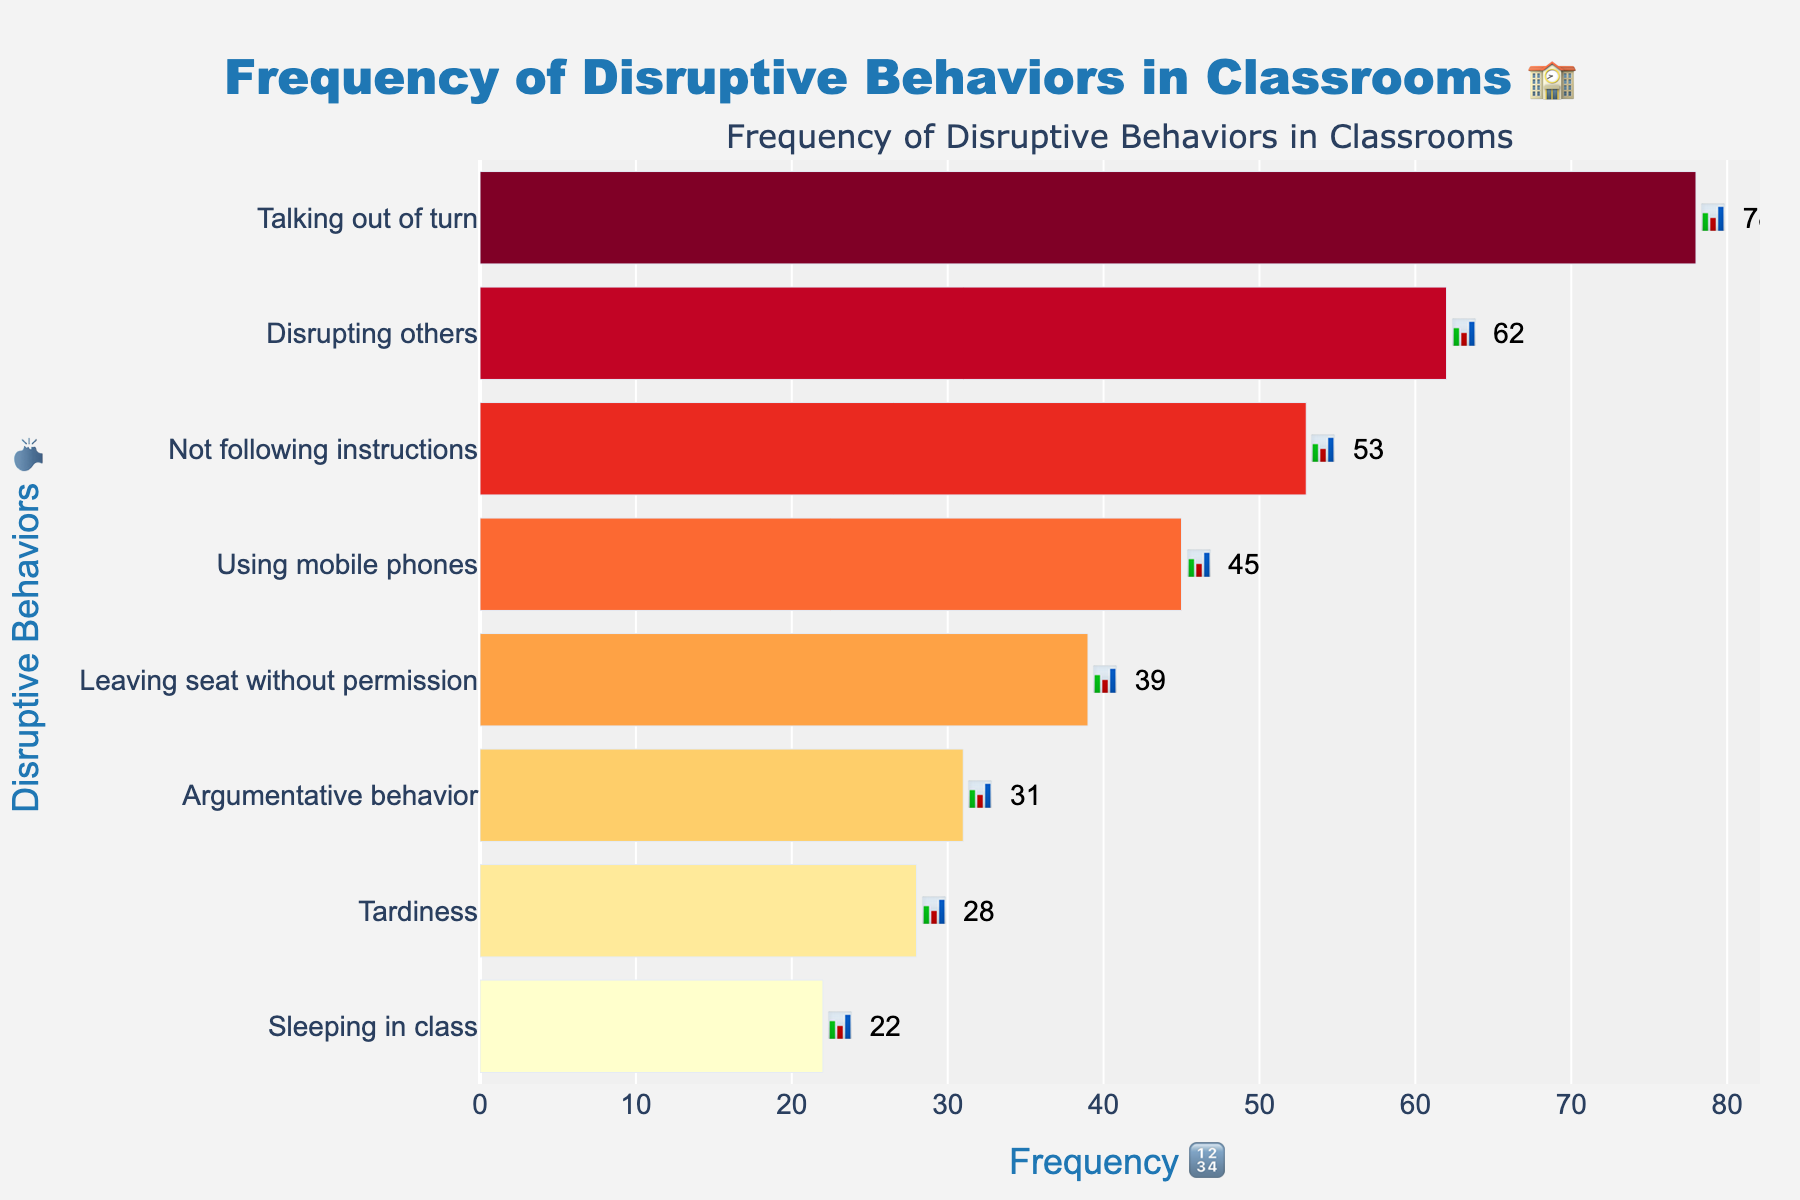What's the title of the chart? The title of the chart is located at the top and is emphasized in larger, bold text. It reads "Frequency of Disruptive Behaviors in Classrooms 🏫".
Answer: Frequency of Disruptive Behaviors in Classrooms 🏫 How many types of disruptive behaviors are reported in the chart? Count the number of different behaviors listed on the y-axis. There are eight types.
Answer: 8 Which disruptive behavior is reported the most frequently? The behavior with the highest bar length represents the highest frequency. "Talking out of turn" has the longest bar.
Answer: Talking out of turn What is the frequency of using mobile phones in class? Locate “Using mobile phones” on the y-axis and find its corresponding bar's length labeled with text. The frequency is 45.
Answer: 45 Which disruptive behavior has the lowest reported frequency? The behavior with the shortest bar is “Sleeping in class,” with a frequency of 22.
Answer: Sleeping in class What is the combined frequency of "Not following instructions" and "Leaving seat without permission"? Add the frequencies of the two behaviors: 53 (Not following instructions) + 39 (Leaving seat without permission). 53 + 39 = 92.
Answer: 92 Are there any behaviors with a frequency greater than 60? If so, which ones? Compare the frequencies of all behaviors to 60. Both "Talking out of turn" (78) and "Disrupting others" (62) have frequencies greater than 60.
Answer: Talking out of turn, Disrupting others How much more frequently is "Argumentative behavior" reported compared to "Tardiness"? Subtract the frequency of "Tardiness" from "Argumentative behavior": 31 (Argumentative behavior) - 28 (Tardiness) = 3.
Answer: 3 Which disruptive behaviors have frequencies below 40? Identify the bars with frequencies less than 40. They are "Leaving seat without permission" (39), "Argumentative behavior" (31), "Tardiness" (28), and "Sleeping in class" (22).
Answer: Leaving seat without permission, Argumentative behavior, Tardiness, Sleeping in class What's the color gradient used in the chart? The colors of the bars seem to follow a gradient from light to dark based on frequency, likely a yellow to red color scale (YlOrRd).
Answer: Yellow to Red (YlOrRd) 